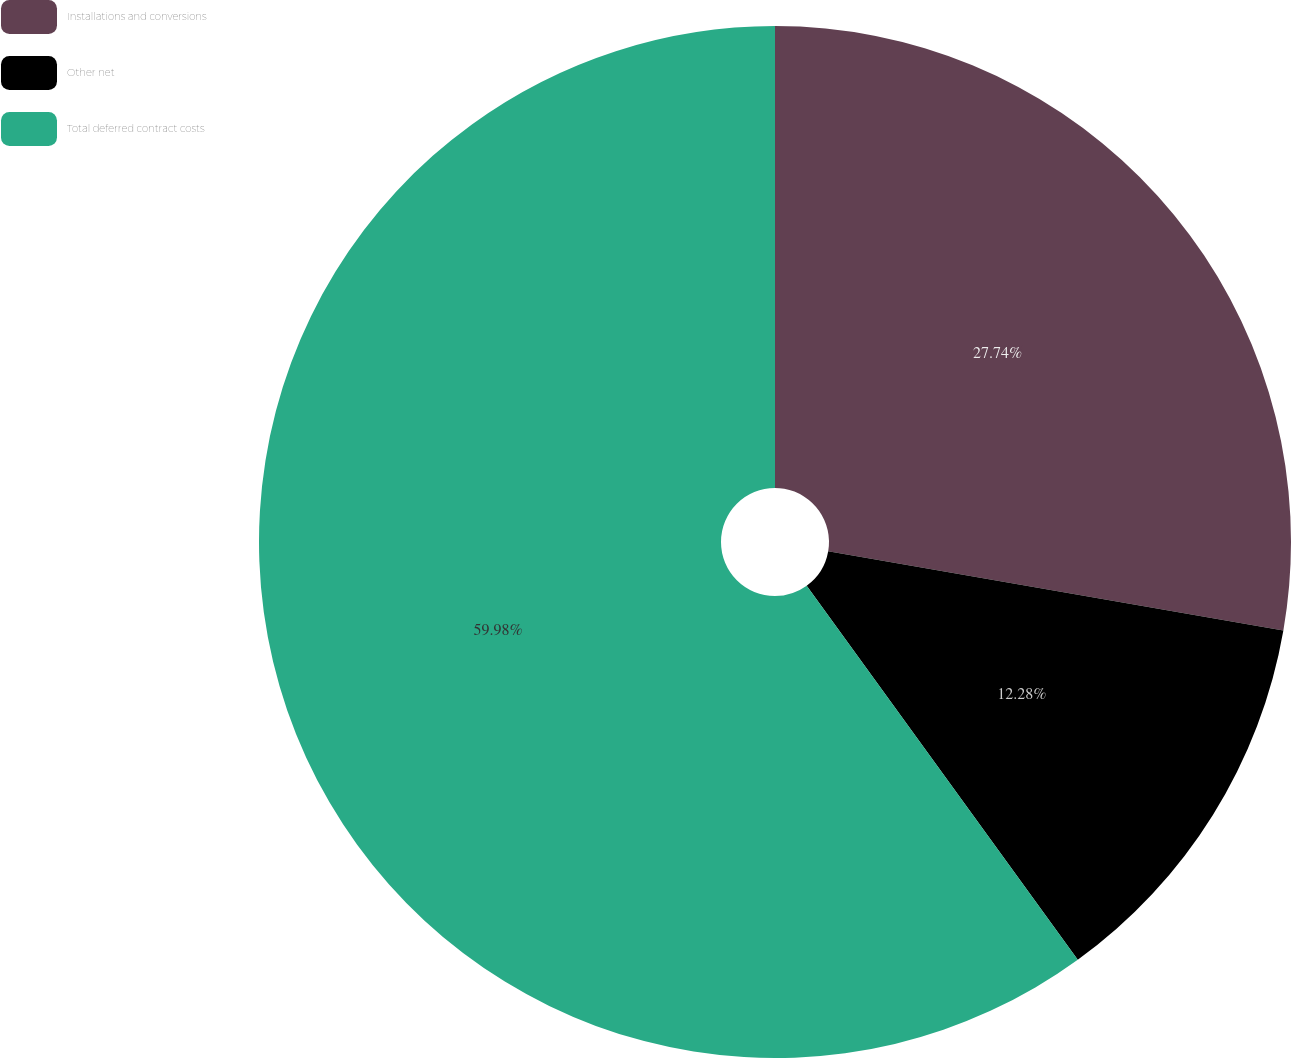<chart> <loc_0><loc_0><loc_500><loc_500><pie_chart><fcel>Installations and conversions<fcel>Other net<fcel>Total deferred contract costs<nl><fcel>27.74%<fcel>12.28%<fcel>59.98%<nl></chart> 